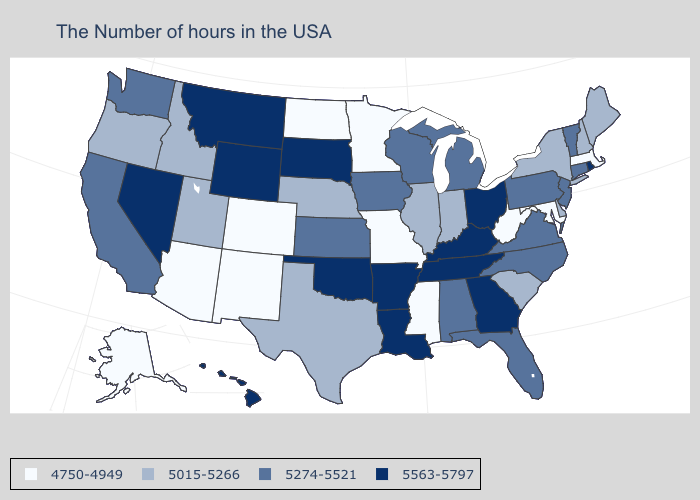Is the legend a continuous bar?
Be succinct. No. Among the states that border West Virginia , which have the highest value?
Give a very brief answer. Ohio, Kentucky. What is the value of South Dakota?
Short answer required. 5563-5797. Name the states that have a value in the range 4750-4949?
Be succinct. Massachusetts, Maryland, West Virginia, Mississippi, Missouri, Minnesota, North Dakota, Colorado, New Mexico, Arizona, Alaska. Does the first symbol in the legend represent the smallest category?
Write a very short answer. Yes. Does Georgia have the highest value in the South?
Quick response, please. Yes. Name the states that have a value in the range 5274-5521?
Quick response, please. Vermont, Connecticut, New Jersey, Pennsylvania, Virginia, North Carolina, Florida, Michigan, Alabama, Wisconsin, Iowa, Kansas, California, Washington. Does Oklahoma have the highest value in the USA?
Concise answer only. Yes. What is the highest value in the MidWest ?
Keep it brief. 5563-5797. Name the states that have a value in the range 5015-5266?
Quick response, please. Maine, New Hampshire, New York, Delaware, South Carolina, Indiana, Illinois, Nebraska, Texas, Utah, Idaho, Oregon. What is the lowest value in the Northeast?
Short answer required. 4750-4949. Among the states that border Idaho , which have the lowest value?
Answer briefly. Utah, Oregon. Name the states that have a value in the range 5563-5797?
Be succinct. Rhode Island, Ohio, Georgia, Kentucky, Tennessee, Louisiana, Arkansas, Oklahoma, South Dakota, Wyoming, Montana, Nevada, Hawaii. Name the states that have a value in the range 5015-5266?
Short answer required. Maine, New Hampshire, New York, Delaware, South Carolina, Indiana, Illinois, Nebraska, Texas, Utah, Idaho, Oregon. Does Nebraska have the lowest value in the USA?
Quick response, please. No. 